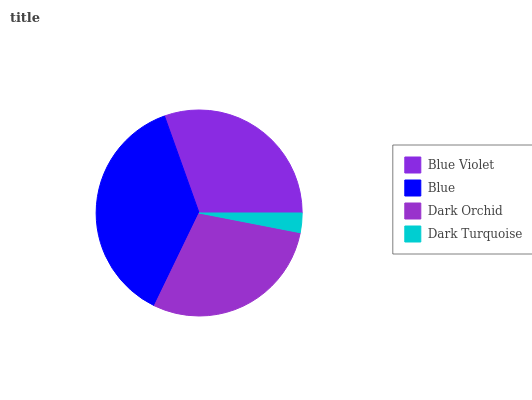Is Dark Turquoise the minimum?
Answer yes or no. Yes. Is Blue the maximum?
Answer yes or no. Yes. Is Dark Orchid the minimum?
Answer yes or no. No. Is Dark Orchid the maximum?
Answer yes or no. No. Is Blue greater than Dark Orchid?
Answer yes or no. Yes. Is Dark Orchid less than Blue?
Answer yes or no. Yes. Is Dark Orchid greater than Blue?
Answer yes or no. No. Is Blue less than Dark Orchid?
Answer yes or no. No. Is Blue Violet the high median?
Answer yes or no. Yes. Is Dark Orchid the low median?
Answer yes or no. Yes. Is Dark Orchid the high median?
Answer yes or no. No. Is Blue Violet the low median?
Answer yes or no. No. 